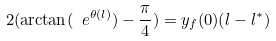Convert formula to latex. <formula><loc_0><loc_0><loc_500><loc_500>2 ( \arctan ( \ e ^ { \theta ( l ) } ) - \frac { \pi } { 4 } ) = y _ { f } ( 0 ) ( l - l ^ { * } )</formula> 